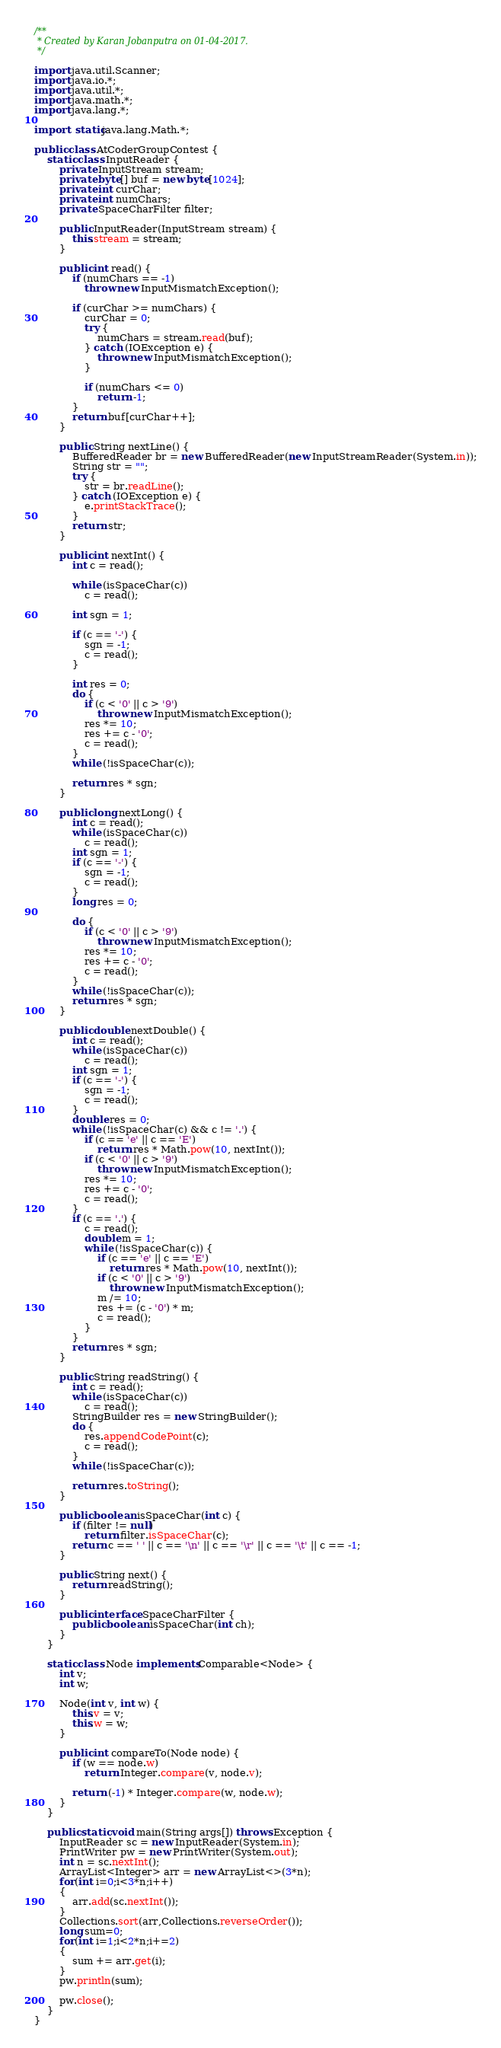Convert code to text. <code><loc_0><loc_0><loc_500><loc_500><_Java_>/**
 * Created by Karan Jobanputra on 01-04-2017.
 */

import java.util.Scanner;
import java.io.*;
import java.util.*;
import java.math.*;
import java.lang.*;

import static java.lang.Math.*;

public class AtCoderGroupContest {
    static class InputReader {
        private InputStream stream;
        private byte[] buf = new byte[1024];
        private int curChar;
        private int numChars;
        private SpaceCharFilter filter;

        public InputReader(InputStream stream) {
            this.stream = stream;
        }

        public int read() {
            if (numChars == -1)
                throw new InputMismatchException();

            if (curChar >= numChars) {
                curChar = 0;
                try {
                    numChars = stream.read(buf);
                } catch (IOException e) {
                    throw new InputMismatchException();
                }

                if (numChars <= 0)
                    return -1;
            }
            return buf[curChar++];
        }

        public String nextLine() {
            BufferedReader br = new BufferedReader(new InputStreamReader(System.in));
            String str = "";
            try {
                str = br.readLine();
            } catch (IOException e) {
                e.printStackTrace();
            }
            return str;
        }

        public int nextInt() {
            int c = read();

            while (isSpaceChar(c))
                c = read();

            int sgn = 1;

            if (c == '-') {
                sgn = -1;
                c = read();
            }

            int res = 0;
            do {
                if (c < '0' || c > '9')
                    throw new InputMismatchException();
                res *= 10;
                res += c - '0';
                c = read();
            }
            while (!isSpaceChar(c));

            return res * sgn;
        }

        public long nextLong() {
            int c = read();
            while (isSpaceChar(c))
                c = read();
            int sgn = 1;
            if (c == '-') {
                sgn = -1;
                c = read();
            }
            long res = 0;

            do {
                if (c < '0' || c > '9')
                    throw new InputMismatchException();
                res *= 10;
                res += c - '0';
                c = read();
            }
            while (!isSpaceChar(c));
            return res * sgn;
        }

        public double nextDouble() {
            int c = read();
            while (isSpaceChar(c))
                c = read();
            int sgn = 1;
            if (c == '-') {
                sgn = -1;
                c = read();
            }
            double res = 0;
            while (!isSpaceChar(c) && c != '.') {
                if (c == 'e' || c == 'E')
                    return res * Math.pow(10, nextInt());
                if (c < '0' || c > '9')
                    throw new InputMismatchException();
                res *= 10;
                res += c - '0';
                c = read();
            }
            if (c == '.') {
                c = read();
                double m = 1;
                while (!isSpaceChar(c)) {
                    if (c == 'e' || c == 'E')
                        return res * Math.pow(10, nextInt());
                    if (c < '0' || c > '9')
                        throw new InputMismatchException();
                    m /= 10;
                    res += (c - '0') * m;
                    c = read();
                }
            }
            return res * sgn;
        }

        public String readString() {
            int c = read();
            while (isSpaceChar(c))
                c = read();
            StringBuilder res = new StringBuilder();
            do {
                res.appendCodePoint(c);
                c = read();
            }
            while (!isSpaceChar(c));

            return res.toString();
        }

        public boolean isSpaceChar(int c) {
            if (filter != null)
                return filter.isSpaceChar(c);
            return c == ' ' || c == '\n' || c == '\r' || c == '\t' || c == -1;
        }

        public String next() {
            return readString();
        }

        public interface SpaceCharFilter {
            public boolean isSpaceChar(int ch);
        }
    }

    static class Node implements Comparable<Node> {
        int v;
        int w;

        Node(int v, int w) {
            this.v = v;
            this.w = w;
        }

        public int compareTo(Node node) {
            if (w == node.w)
                return Integer.compare(v, node.v);

            return (-1) * Integer.compare(w, node.w);
        }
    }

    public static void main(String args[]) throws Exception {
        InputReader sc = new InputReader(System.in);
        PrintWriter pw = new PrintWriter(System.out);
        int n = sc.nextInt();
        ArrayList<Integer> arr = new ArrayList<>(3*n);
        for(int i=0;i<3*n;i++)
        {
            arr.add(sc.nextInt());
        }
        Collections.sort(arr,Collections.reverseOrder());
        long sum=0;
        for(int i=1;i<2*n;i+=2)
        {
            sum += arr.get(i);
        }
        pw.println(sum);

        pw.close();
    }
}</code> 